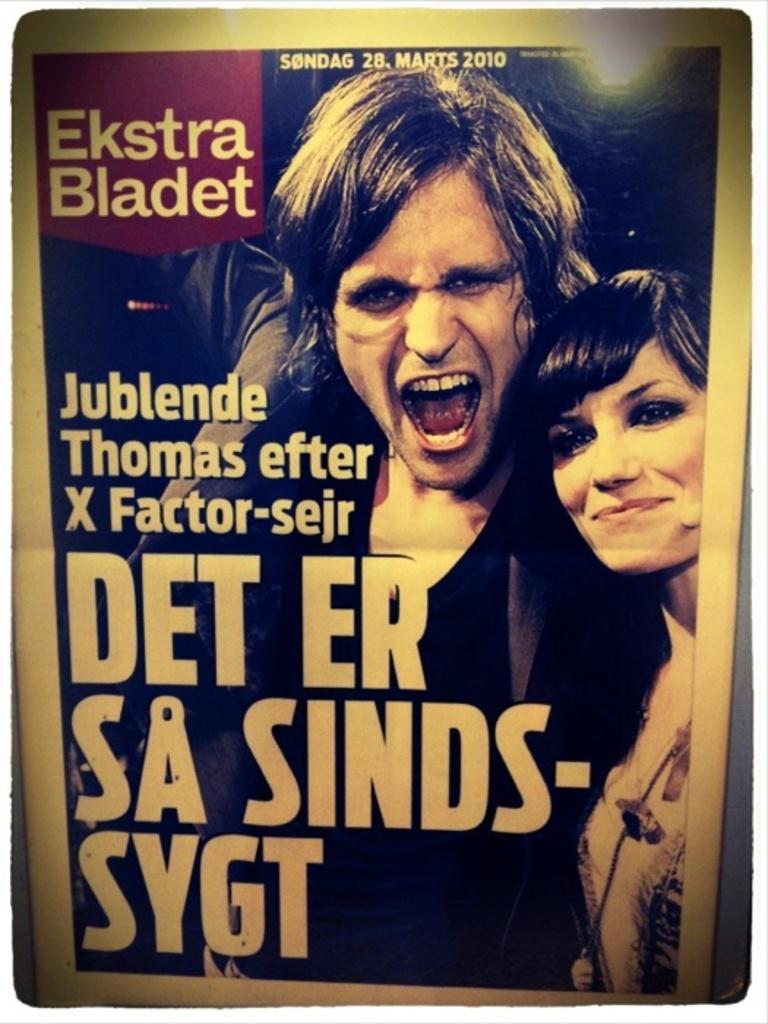Can you describe this image briefly? In the picture I can see the poster. On the poster I can see two persons. There is a text on the left side. I can see a woman on the right side and she is smiling. 